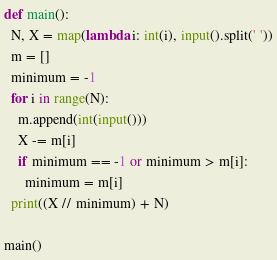Convert code to text. <code><loc_0><loc_0><loc_500><loc_500><_Python_>def main():
  N, X = map(lambda i: int(i), input().split(' '))
  m = []
  minimum = -1
  for i in range(N):
    m.append(int(input()))
    X -= m[i]
    if minimum == -1 or minimum > m[i]:
      minimum = m[i]
  print((X // minimum) + N)

main()
</code> 